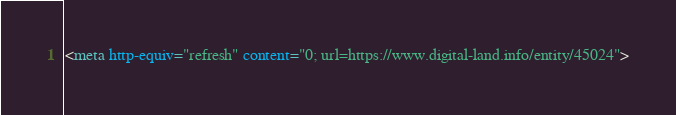Convert code to text. <code><loc_0><loc_0><loc_500><loc_500><_HTML_><meta http-equiv="refresh" content="0; url=https://www.digital-land.info/entity/45024"></code> 